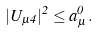<formula> <loc_0><loc_0><loc_500><loc_500>| U _ { \mu 4 } | ^ { 2 } \leq a _ { \mu } ^ { 0 } \, .</formula> 